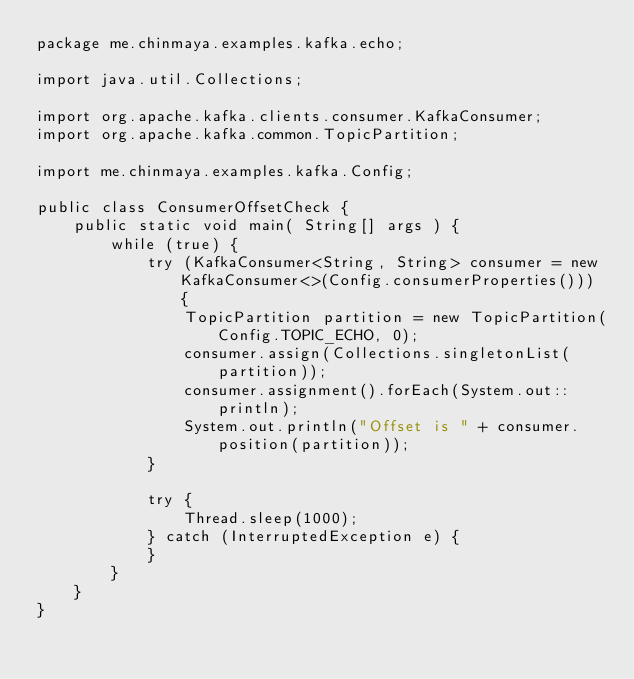Convert code to text. <code><loc_0><loc_0><loc_500><loc_500><_Java_>package me.chinmaya.examples.kafka.echo;

import java.util.Collections;

import org.apache.kafka.clients.consumer.KafkaConsumer;
import org.apache.kafka.common.TopicPartition;

import me.chinmaya.examples.kafka.Config;

public class ConsumerOffsetCheck {
    public static void main( String[] args ) {
		while (true) {
			try (KafkaConsumer<String, String> consumer = new KafkaConsumer<>(Config.consumerProperties())) {
				TopicPartition partition = new TopicPartition(Config.TOPIC_ECHO, 0);
				consumer.assign(Collections.singletonList(partition));
				consumer.assignment().forEach(System.out::println);
				System.out.println("Offset is " + consumer.position(partition));
			}
			
			try {
				Thread.sleep(1000);
			} catch (InterruptedException e) {
			}
		}
    }
}
</code> 